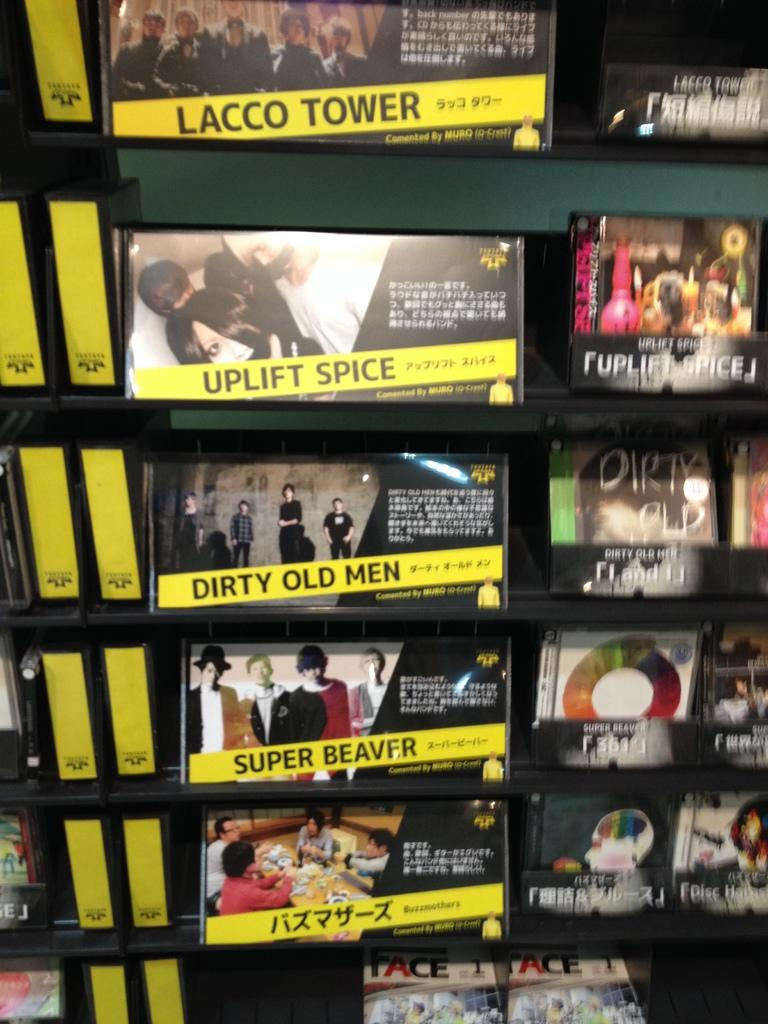Provide a one-sentence caption for the provided image. Super Beaver is for sale with Uplift Spice and other CDs. 